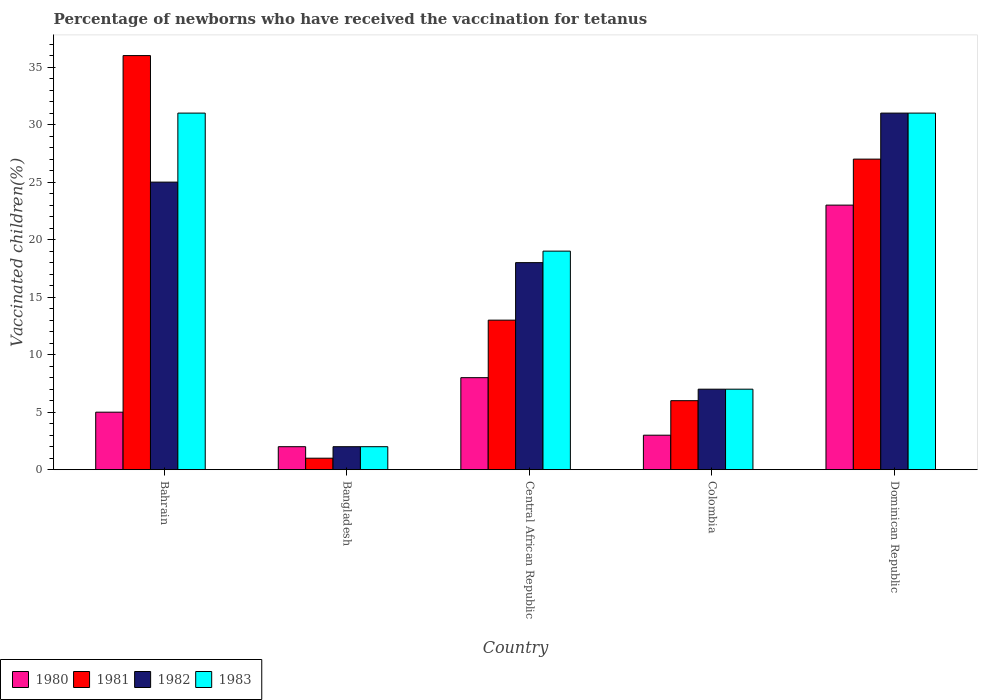How many different coloured bars are there?
Your response must be concise. 4. Are the number of bars on each tick of the X-axis equal?
Your response must be concise. Yes. How many bars are there on the 2nd tick from the left?
Provide a succinct answer. 4. How many bars are there on the 3rd tick from the right?
Provide a succinct answer. 4. What is the label of the 4th group of bars from the left?
Your answer should be compact. Colombia. In how many cases, is the number of bars for a given country not equal to the number of legend labels?
Ensure brevity in your answer.  0. Across all countries, what is the maximum percentage of vaccinated children in 1980?
Offer a very short reply. 23. In which country was the percentage of vaccinated children in 1983 maximum?
Keep it short and to the point. Bahrain. In which country was the percentage of vaccinated children in 1981 minimum?
Provide a short and direct response. Bangladesh. What is the total percentage of vaccinated children in 1980 in the graph?
Give a very brief answer. 41. What is the difference between the percentage of vaccinated children in 1983 in Bahrain and that in Colombia?
Offer a terse response. 24. What is the average percentage of vaccinated children in 1983 per country?
Make the answer very short. 18. What is the ratio of the percentage of vaccinated children in 1981 in Colombia to that in Dominican Republic?
Your answer should be very brief. 0.22. What is the difference between the highest and the second highest percentage of vaccinated children in 1981?
Your answer should be very brief. -9. What is the difference between the highest and the lowest percentage of vaccinated children in 1981?
Keep it short and to the point. 35. In how many countries, is the percentage of vaccinated children in 1980 greater than the average percentage of vaccinated children in 1980 taken over all countries?
Keep it short and to the point. 1. Is it the case that in every country, the sum of the percentage of vaccinated children in 1983 and percentage of vaccinated children in 1982 is greater than the sum of percentage of vaccinated children in 1980 and percentage of vaccinated children in 1981?
Your response must be concise. No. What does the 4th bar from the right in Central African Republic represents?
Offer a terse response. 1980. Is it the case that in every country, the sum of the percentage of vaccinated children in 1981 and percentage of vaccinated children in 1983 is greater than the percentage of vaccinated children in 1982?
Provide a succinct answer. Yes. How many countries are there in the graph?
Provide a succinct answer. 5. What is the difference between two consecutive major ticks on the Y-axis?
Give a very brief answer. 5. Where does the legend appear in the graph?
Provide a succinct answer. Bottom left. What is the title of the graph?
Make the answer very short. Percentage of newborns who have received the vaccination for tetanus. What is the label or title of the X-axis?
Give a very brief answer. Country. What is the label or title of the Y-axis?
Your answer should be compact. Vaccinated children(%). What is the Vaccinated children(%) in 1980 in Bahrain?
Your response must be concise. 5. What is the Vaccinated children(%) of 1981 in Bahrain?
Your response must be concise. 36. What is the Vaccinated children(%) of 1980 in Bangladesh?
Ensure brevity in your answer.  2. What is the Vaccinated children(%) of 1982 in Bangladesh?
Keep it short and to the point. 2. What is the Vaccinated children(%) of 1982 in Central African Republic?
Your answer should be very brief. 18. What is the Vaccinated children(%) in 1980 in Colombia?
Give a very brief answer. 3. What is the Vaccinated children(%) of 1982 in Colombia?
Offer a terse response. 7. What is the Vaccinated children(%) of 1983 in Colombia?
Offer a terse response. 7. What is the Vaccinated children(%) of 1980 in Dominican Republic?
Your answer should be very brief. 23. Across all countries, what is the maximum Vaccinated children(%) of 1980?
Ensure brevity in your answer.  23. Across all countries, what is the maximum Vaccinated children(%) of 1982?
Offer a terse response. 31. Across all countries, what is the maximum Vaccinated children(%) of 1983?
Your response must be concise. 31. Across all countries, what is the minimum Vaccinated children(%) in 1981?
Your answer should be very brief. 1. What is the total Vaccinated children(%) in 1980 in the graph?
Ensure brevity in your answer.  41. What is the total Vaccinated children(%) of 1981 in the graph?
Your answer should be compact. 83. What is the difference between the Vaccinated children(%) in 1980 in Bahrain and that in Bangladesh?
Provide a short and direct response. 3. What is the difference between the Vaccinated children(%) of 1981 in Bahrain and that in Bangladesh?
Make the answer very short. 35. What is the difference between the Vaccinated children(%) of 1983 in Bahrain and that in Bangladesh?
Ensure brevity in your answer.  29. What is the difference between the Vaccinated children(%) in 1983 in Bahrain and that in Central African Republic?
Ensure brevity in your answer.  12. What is the difference between the Vaccinated children(%) in 1980 in Bahrain and that in Colombia?
Offer a very short reply. 2. What is the difference between the Vaccinated children(%) of 1982 in Bahrain and that in Colombia?
Offer a very short reply. 18. What is the difference between the Vaccinated children(%) in 1983 in Bahrain and that in Colombia?
Your response must be concise. 24. What is the difference between the Vaccinated children(%) in 1980 in Bahrain and that in Dominican Republic?
Offer a terse response. -18. What is the difference between the Vaccinated children(%) of 1981 in Bahrain and that in Dominican Republic?
Give a very brief answer. 9. What is the difference between the Vaccinated children(%) in 1983 in Bahrain and that in Dominican Republic?
Provide a succinct answer. 0. What is the difference between the Vaccinated children(%) in 1981 in Bangladesh and that in Central African Republic?
Offer a terse response. -12. What is the difference between the Vaccinated children(%) of 1981 in Bangladesh and that in Colombia?
Provide a succinct answer. -5. What is the difference between the Vaccinated children(%) of 1983 in Bangladesh and that in Colombia?
Offer a very short reply. -5. What is the difference between the Vaccinated children(%) of 1983 in Bangladesh and that in Dominican Republic?
Your answer should be very brief. -29. What is the difference between the Vaccinated children(%) of 1981 in Central African Republic and that in Colombia?
Offer a terse response. 7. What is the difference between the Vaccinated children(%) in 1981 in Central African Republic and that in Dominican Republic?
Ensure brevity in your answer.  -14. What is the difference between the Vaccinated children(%) of 1980 in Colombia and that in Dominican Republic?
Offer a terse response. -20. What is the difference between the Vaccinated children(%) of 1983 in Colombia and that in Dominican Republic?
Provide a succinct answer. -24. What is the difference between the Vaccinated children(%) in 1980 in Bahrain and the Vaccinated children(%) in 1982 in Bangladesh?
Ensure brevity in your answer.  3. What is the difference between the Vaccinated children(%) of 1982 in Bahrain and the Vaccinated children(%) of 1983 in Bangladesh?
Your answer should be very brief. 23. What is the difference between the Vaccinated children(%) in 1980 in Bahrain and the Vaccinated children(%) in 1981 in Central African Republic?
Your response must be concise. -8. What is the difference between the Vaccinated children(%) of 1980 in Bahrain and the Vaccinated children(%) of 1983 in Central African Republic?
Your response must be concise. -14. What is the difference between the Vaccinated children(%) in 1981 in Bahrain and the Vaccinated children(%) in 1983 in Central African Republic?
Provide a short and direct response. 17. What is the difference between the Vaccinated children(%) of 1982 in Bahrain and the Vaccinated children(%) of 1983 in Central African Republic?
Offer a terse response. 6. What is the difference between the Vaccinated children(%) in 1980 in Bahrain and the Vaccinated children(%) in 1982 in Colombia?
Your response must be concise. -2. What is the difference between the Vaccinated children(%) in 1981 in Bahrain and the Vaccinated children(%) in 1982 in Colombia?
Provide a succinct answer. 29. What is the difference between the Vaccinated children(%) of 1981 in Bahrain and the Vaccinated children(%) of 1983 in Colombia?
Your answer should be very brief. 29. What is the difference between the Vaccinated children(%) of 1981 in Bahrain and the Vaccinated children(%) of 1982 in Dominican Republic?
Provide a succinct answer. 5. What is the difference between the Vaccinated children(%) of 1980 in Bangladesh and the Vaccinated children(%) of 1981 in Central African Republic?
Make the answer very short. -11. What is the difference between the Vaccinated children(%) in 1980 in Bangladesh and the Vaccinated children(%) in 1982 in Central African Republic?
Your answer should be compact. -16. What is the difference between the Vaccinated children(%) of 1980 in Bangladesh and the Vaccinated children(%) of 1983 in Central African Republic?
Make the answer very short. -17. What is the difference between the Vaccinated children(%) in 1981 in Bangladesh and the Vaccinated children(%) in 1982 in Central African Republic?
Offer a terse response. -17. What is the difference between the Vaccinated children(%) in 1982 in Bangladesh and the Vaccinated children(%) in 1983 in Central African Republic?
Ensure brevity in your answer.  -17. What is the difference between the Vaccinated children(%) of 1980 in Bangladesh and the Vaccinated children(%) of 1981 in Colombia?
Keep it short and to the point. -4. What is the difference between the Vaccinated children(%) in 1980 in Bangladesh and the Vaccinated children(%) in 1982 in Colombia?
Provide a short and direct response. -5. What is the difference between the Vaccinated children(%) of 1980 in Bangladesh and the Vaccinated children(%) of 1983 in Colombia?
Provide a short and direct response. -5. What is the difference between the Vaccinated children(%) in 1981 in Bangladesh and the Vaccinated children(%) in 1983 in Colombia?
Keep it short and to the point. -6. What is the difference between the Vaccinated children(%) in 1980 in Bangladesh and the Vaccinated children(%) in 1982 in Dominican Republic?
Provide a succinct answer. -29. What is the difference between the Vaccinated children(%) of 1982 in Bangladesh and the Vaccinated children(%) of 1983 in Dominican Republic?
Your answer should be very brief. -29. What is the difference between the Vaccinated children(%) in 1980 in Central African Republic and the Vaccinated children(%) in 1983 in Colombia?
Your answer should be compact. 1. What is the difference between the Vaccinated children(%) in 1981 in Central African Republic and the Vaccinated children(%) in 1982 in Colombia?
Provide a succinct answer. 6. What is the difference between the Vaccinated children(%) in 1981 in Central African Republic and the Vaccinated children(%) in 1983 in Colombia?
Offer a terse response. 6. What is the difference between the Vaccinated children(%) of 1982 in Central African Republic and the Vaccinated children(%) of 1983 in Colombia?
Provide a succinct answer. 11. What is the difference between the Vaccinated children(%) in 1981 in Central African Republic and the Vaccinated children(%) in 1983 in Dominican Republic?
Ensure brevity in your answer.  -18. What is the difference between the Vaccinated children(%) of 1982 in Central African Republic and the Vaccinated children(%) of 1983 in Dominican Republic?
Your response must be concise. -13. What is the difference between the Vaccinated children(%) in 1980 in Colombia and the Vaccinated children(%) in 1983 in Dominican Republic?
Offer a very short reply. -28. What is the difference between the Vaccinated children(%) in 1981 in Colombia and the Vaccinated children(%) in 1983 in Dominican Republic?
Provide a succinct answer. -25. What is the difference between the Vaccinated children(%) in 1982 in Colombia and the Vaccinated children(%) in 1983 in Dominican Republic?
Your answer should be compact. -24. What is the average Vaccinated children(%) of 1980 per country?
Give a very brief answer. 8.2. What is the average Vaccinated children(%) in 1983 per country?
Provide a short and direct response. 18. What is the difference between the Vaccinated children(%) of 1980 and Vaccinated children(%) of 1981 in Bahrain?
Give a very brief answer. -31. What is the difference between the Vaccinated children(%) of 1980 and Vaccinated children(%) of 1982 in Bahrain?
Provide a succinct answer. -20. What is the difference between the Vaccinated children(%) in 1980 and Vaccinated children(%) in 1983 in Bahrain?
Offer a terse response. -26. What is the difference between the Vaccinated children(%) of 1981 and Vaccinated children(%) of 1982 in Bahrain?
Your answer should be compact. 11. What is the difference between the Vaccinated children(%) of 1981 and Vaccinated children(%) of 1983 in Bahrain?
Your answer should be very brief. 5. What is the difference between the Vaccinated children(%) of 1980 and Vaccinated children(%) of 1981 in Bangladesh?
Offer a very short reply. 1. What is the difference between the Vaccinated children(%) of 1980 and Vaccinated children(%) of 1982 in Bangladesh?
Your answer should be compact. 0. What is the difference between the Vaccinated children(%) in 1982 and Vaccinated children(%) in 1983 in Bangladesh?
Your answer should be compact. 0. What is the difference between the Vaccinated children(%) of 1980 and Vaccinated children(%) of 1982 in Central African Republic?
Your answer should be compact. -10. What is the difference between the Vaccinated children(%) in 1980 and Vaccinated children(%) in 1983 in Colombia?
Your response must be concise. -4. What is the difference between the Vaccinated children(%) in 1980 and Vaccinated children(%) in 1981 in Dominican Republic?
Your answer should be compact. -4. What is the difference between the Vaccinated children(%) in 1980 and Vaccinated children(%) in 1982 in Dominican Republic?
Your response must be concise. -8. What is the difference between the Vaccinated children(%) in 1980 and Vaccinated children(%) in 1983 in Dominican Republic?
Provide a succinct answer. -8. What is the difference between the Vaccinated children(%) in 1981 and Vaccinated children(%) in 1982 in Dominican Republic?
Make the answer very short. -4. What is the difference between the Vaccinated children(%) in 1981 and Vaccinated children(%) in 1983 in Dominican Republic?
Make the answer very short. -4. What is the ratio of the Vaccinated children(%) in 1981 in Bahrain to that in Bangladesh?
Ensure brevity in your answer.  36. What is the ratio of the Vaccinated children(%) of 1983 in Bahrain to that in Bangladesh?
Ensure brevity in your answer.  15.5. What is the ratio of the Vaccinated children(%) in 1980 in Bahrain to that in Central African Republic?
Provide a succinct answer. 0.62. What is the ratio of the Vaccinated children(%) of 1981 in Bahrain to that in Central African Republic?
Offer a terse response. 2.77. What is the ratio of the Vaccinated children(%) of 1982 in Bahrain to that in Central African Republic?
Offer a very short reply. 1.39. What is the ratio of the Vaccinated children(%) in 1983 in Bahrain to that in Central African Republic?
Your response must be concise. 1.63. What is the ratio of the Vaccinated children(%) in 1982 in Bahrain to that in Colombia?
Offer a very short reply. 3.57. What is the ratio of the Vaccinated children(%) of 1983 in Bahrain to that in Colombia?
Provide a succinct answer. 4.43. What is the ratio of the Vaccinated children(%) of 1980 in Bahrain to that in Dominican Republic?
Offer a very short reply. 0.22. What is the ratio of the Vaccinated children(%) in 1982 in Bahrain to that in Dominican Republic?
Keep it short and to the point. 0.81. What is the ratio of the Vaccinated children(%) in 1983 in Bahrain to that in Dominican Republic?
Provide a succinct answer. 1. What is the ratio of the Vaccinated children(%) of 1980 in Bangladesh to that in Central African Republic?
Keep it short and to the point. 0.25. What is the ratio of the Vaccinated children(%) of 1981 in Bangladesh to that in Central African Republic?
Your response must be concise. 0.08. What is the ratio of the Vaccinated children(%) of 1983 in Bangladesh to that in Central African Republic?
Ensure brevity in your answer.  0.11. What is the ratio of the Vaccinated children(%) in 1981 in Bangladesh to that in Colombia?
Your answer should be very brief. 0.17. What is the ratio of the Vaccinated children(%) in 1982 in Bangladesh to that in Colombia?
Give a very brief answer. 0.29. What is the ratio of the Vaccinated children(%) in 1983 in Bangladesh to that in Colombia?
Offer a terse response. 0.29. What is the ratio of the Vaccinated children(%) of 1980 in Bangladesh to that in Dominican Republic?
Your response must be concise. 0.09. What is the ratio of the Vaccinated children(%) in 1981 in Bangladesh to that in Dominican Republic?
Make the answer very short. 0.04. What is the ratio of the Vaccinated children(%) in 1982 in Bangladesh to that in Dominican Republic?
Give a very brief answer. 0.06. What is the ratio of the Vaccinated children(%) of 1983 in Bangladesh to that in Dominican Republic?
Provide a succinct answer. 0.06. What is the ratio of the Vaccinated children(%) of 1980 in Central African Republic to that in Colombia?
Give a very brief answer. 2.67. What is the ratio of the Vaccinated children(%) of 1981 in Central African Republic to that in Colombia?
Provide a short and direct response. 2.17. What is the ratio of the Vaccinated children(%) of 1982 in Central African Republic to that in Colombia?
Offer a very short reply. 2.57. What is the ratio of the Vaccinated children(%) of 1983 in Central African Republic to that in Colombia?
Give a very brief answer. 2.71. What is the ratio of the Vaccinated children(%) in 1980 in Central African Republic to that in Dominican Republic?
Give a very brief answer. 0.35. What is the ratio of the Vaccinated children(%) of 1981 in Central African Republic to that in Dominican Republic?
Make the answer very short. 0.48. What is the ratio of the Vaccinated children(%) in 1982 in Central African Republic to that in Dominican Republic?
Provide a short and direct response. 0.58. What is the ratio of the Vaccinated children(%) of 1983 in Central African Republic to that in Dominican Republic?
Make the answer very short. 0.61. What is the ratio of the Vaccinated children(%) of 1980 in Colombia to that in Dominican Republic?
Offer a terse response. 0.13. What is the ratio of the Vaccinated children(%) of 1981 in Colombia to that in Dominican Republic?
Provide a succinct answer. 0.22. What is the ratio of the Vaccinated children(%) in 1982 in Colombia to that in Dominican Republic?
Make the answer very short. 0.23. What is the ratio of the Vaccinated children(%) of 1983 in Colombia to that in Dominican Republic?
Keep it short and to the point. 0.23. What is the difference between the highest and the second highest Vaccinated children(%) of 1981?
Offer a terse response. 9. What is the difference between the highest and the second highest Vaccinated children(%) in 1983?
Give a very brief answer. 0. What is the difference between the highest and the lowest Vaccinated children(%) of 1982?
Your response must be concise. 29. 